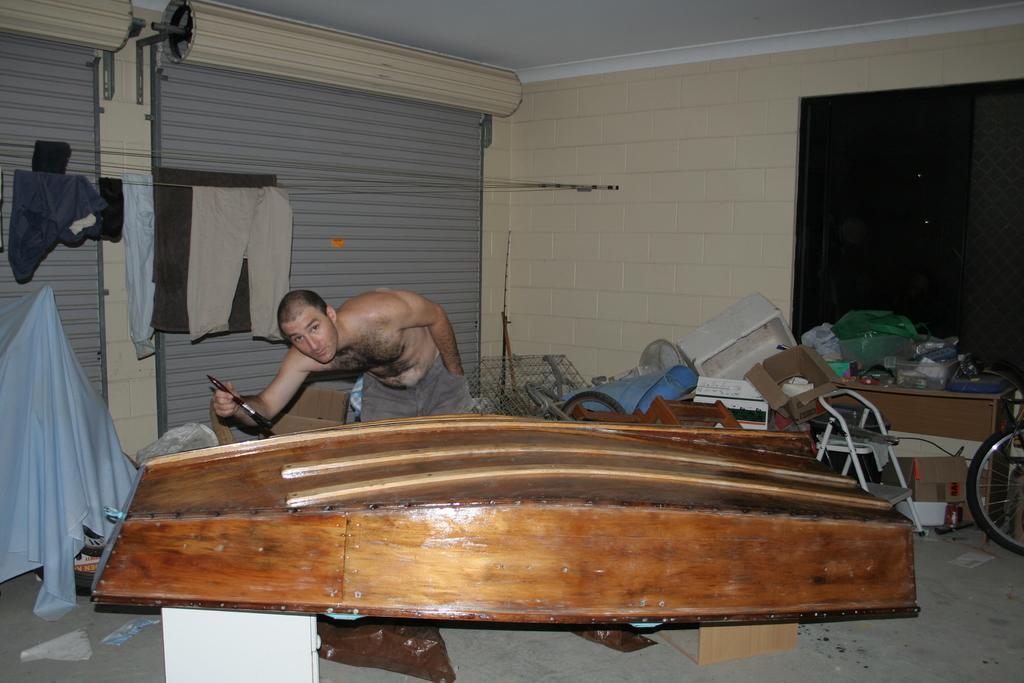Can you describe this image briefly? In this picture I can see a man standing and holding a paint brush near a wooden object. There are cardboard boxes, chair, wheel, clothes, table, ladder, shutters and some other objects, and in the background there are walls and a window. 